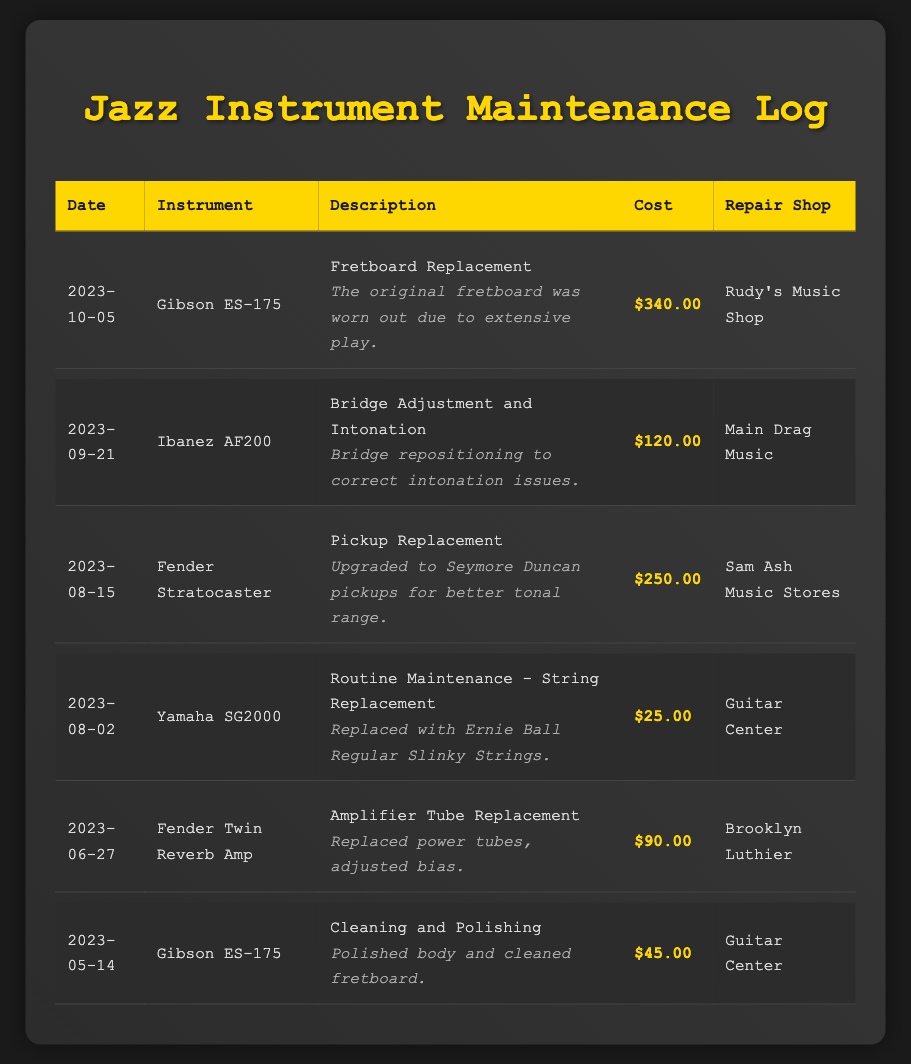what is the most recent maintenance date? The most recent maintenance date is the last entry in the log, which is 2023-10-05.
Answer: 2023-10-05 how much did the fretboard replacement on the Gibson ES-175 cost? The cost for the fretboard replacement on the Gibson ES-175 is listed in the log as $340.00.
Answer: $340.00 which instrument had routine maintenance on August 2, 2023? The log indicates that the Yamaha SG2000 had routine maintenance on August 2, 2023.
Answer: Yamaha SG2000 who performed the pickup replacement on the Fender Stratocaster? The Fender Stratocaster had pickup replacement performed by Sam Ash Music Stores, as indicated in the log.
Answer: Sam Ash Music Stores what was the total cost of repairs for the Gibson ES-175? The total cost of repairs for the Gibson ES-175 includes $340.00 for the fretboard replacement and $45.00 for cleaning and polishing, which sums up to $385.00.
Answer: $385.00 how many entries are listed in the maintenance log? The maintenance log contains a total of 6 entries, each representing a different maintenance event.
Answer: 6 what type of maintenance was done on the Fender Twin Reverb Amp? The maintenance done on the Fender Twin Reverb Amp was amplifier tube replacement.
Answer: Amplifier Tube Replacement who was the repair shop for the bridge adjustment on the Ibanez AF200? The repair shop for the bridge adjustment on the Ibanez AF200 was Main Drag Music.
Answer: Main Drag Music 